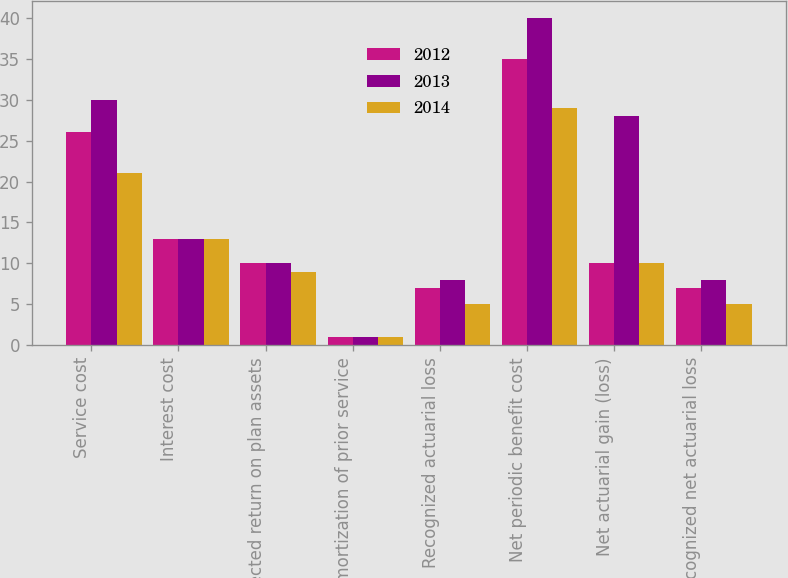<chart> <loc_0><loc_0><loc_500><loc_500><stacked_bar_chart><ecel><fcel>Service cost<fcel>Interest cost<fcel>Expected return on plan assets<fcel>Amortization of prior service<fcel>Recognized actuarial loss<fcel>Net periodic benefit cost<fcel>Net actuarial gain (loss)<fcel>Recognized net actuarial loss<nl><fcel>2012<fcel>26<fcel>13<fcel>10<fcel>1<fcel>7<fcel>35<fcel>10<fcel>7<nl><fcel>2013<fcel>30<fcel>13<fcel>10<fcel>1<fcel>8<fcel>40<fcel>28<fcel>8<nl><fcel>2014<fcel>21<fcel>13<fcel>9<fcel>1<fcel>5<fcel>29<fcel>10<fcel>5<nl></chart> 